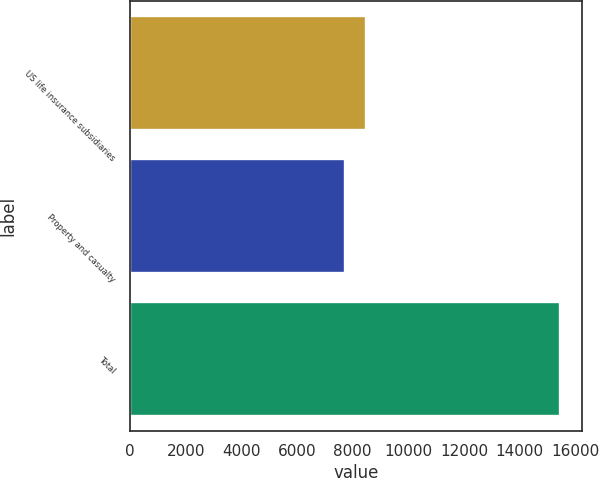Convert chart. <chart><loc_0><loc_0><loc_500><loc_500><bar_chart><fcel>US life insurance subsidiaries<fcel>Property and casualty<fcel>Total<nl><fcel>8494.1<fcel>7721<fcel>15452<nl></chart> 